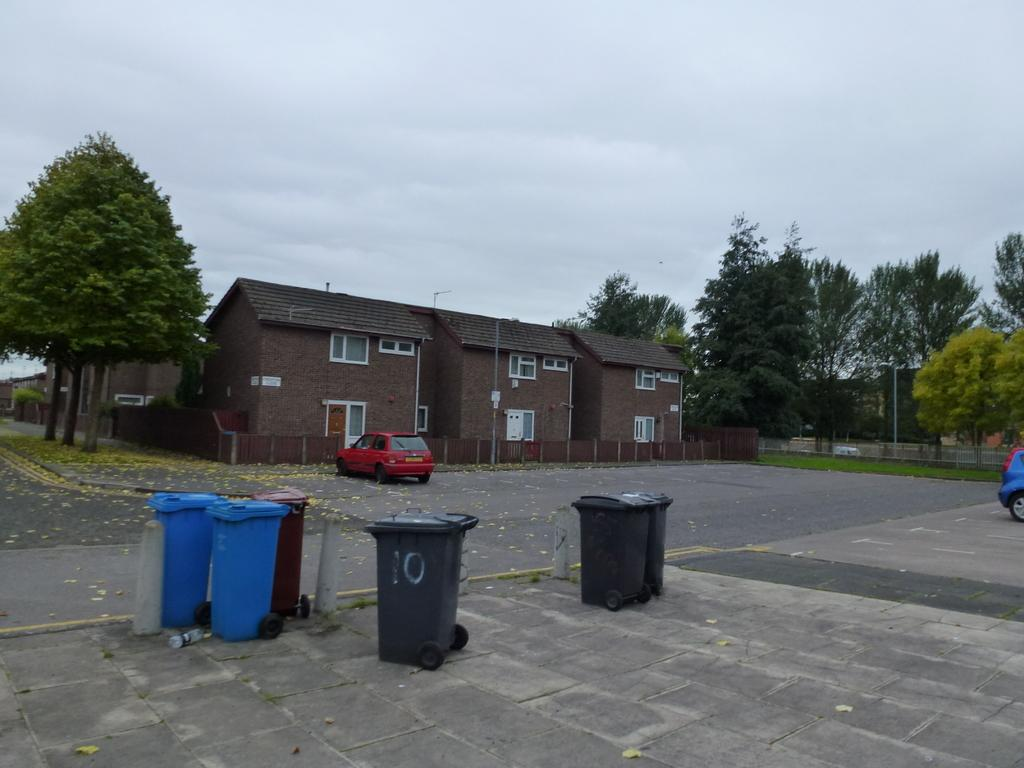<image>
Give a short and clear explanation of the subsequent image. A green garbage can with the number 10 on it sits across the street from some brick apartments. 